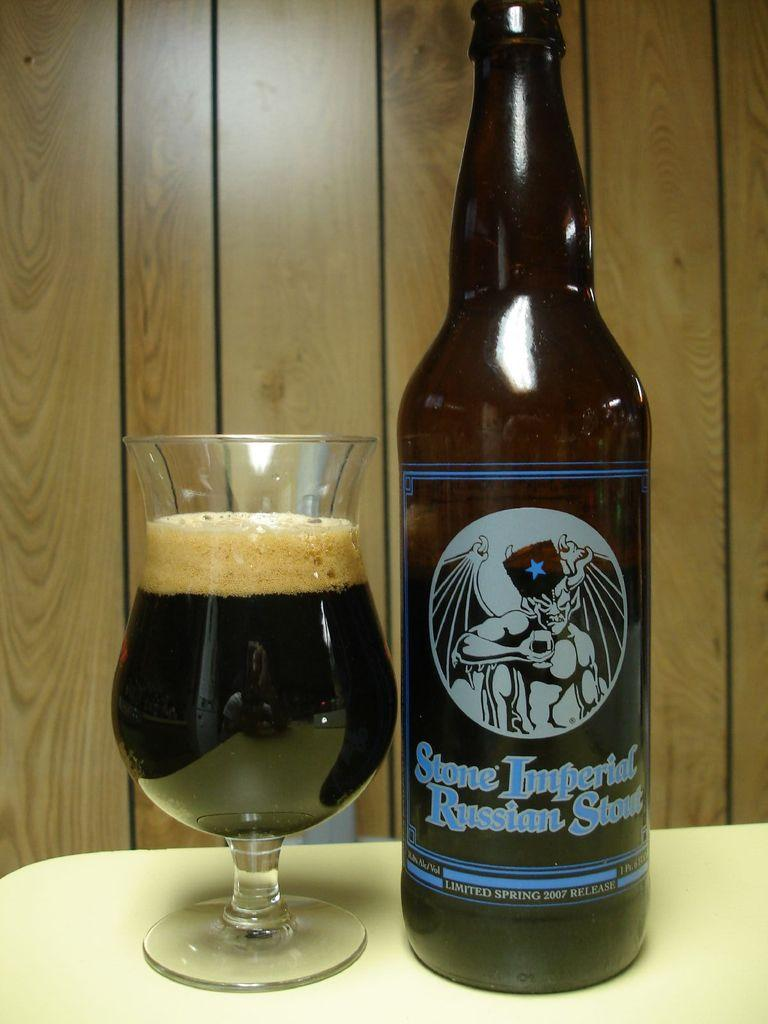<image>
Summarize the visual content of the image. The label on a bottle of beer says Stone Imperial Russian Stout. 